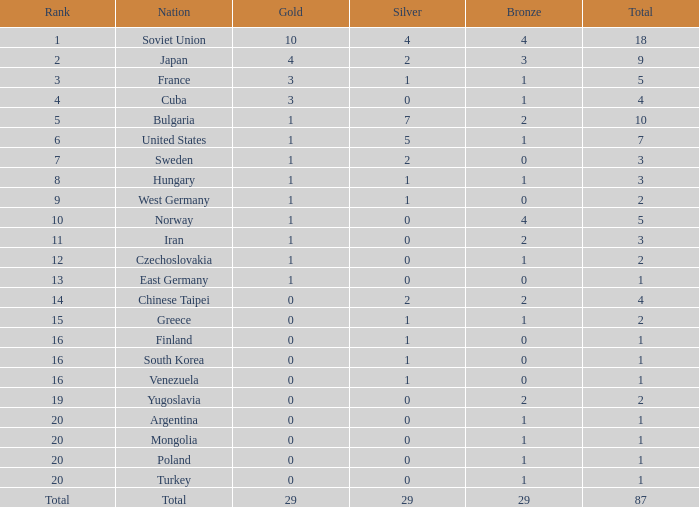What is the sum of gold medals for a rank of 14? 0.0. 